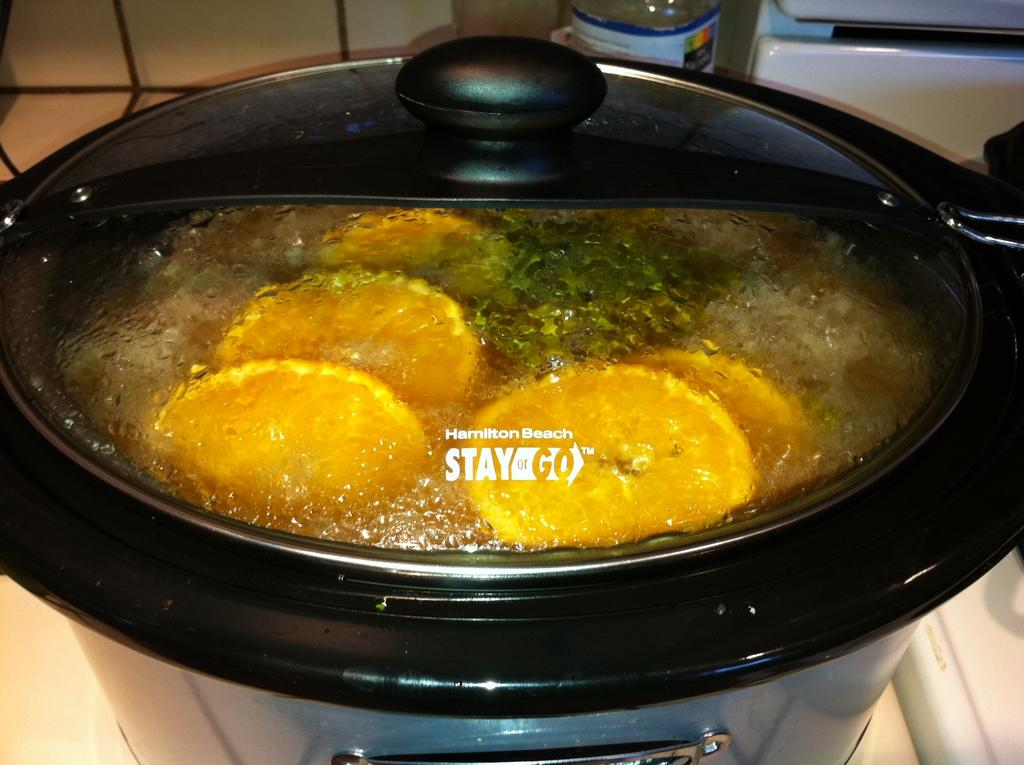<image>
Offer a succinct explanation of the picture presented. a close up of the lid of a Hamilton Beach slow cooker 